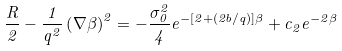Convert formula to latex. <formula><loc_0><loc_0><loc_500><loc_500>\frac { R } { 2 } - \frac { 1 } { q ^ { 2 } } \left ( \nabla \beta \right ) ^ { 2 } = - \frac { \sigma _ { 0 } ^ { 2 } } { 4 } e ^ { - [ 2 + ( 2 b / q ) ] \beta } + c _ { 2 } e ^ { - 2 \beta }</formula> 